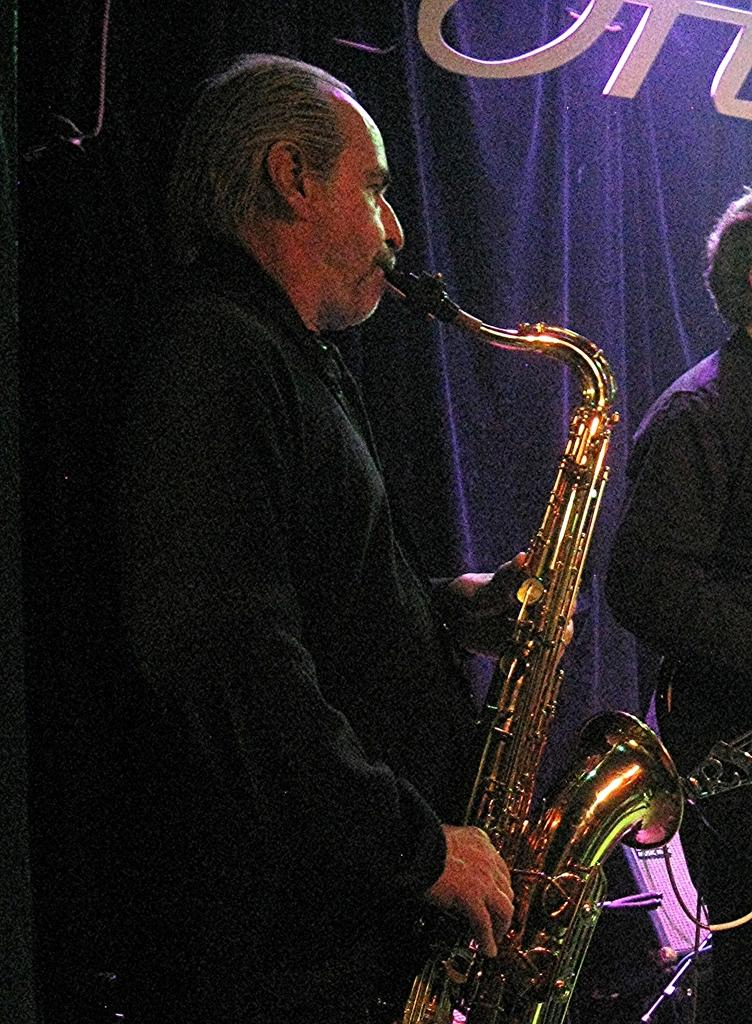What is the man in the image doing? The man is playing the trumpet. What is the man wearing in the image? The man is wearing a black color coat. Can you describe the person on the right side of the image? There is another person on the right side of the image, but no specific details are provided. What can be seen in the background of the image? There is a blue color curtain in the image. What type of match is the man playing in the image? There is no match or competition mentioned in the image; the man is simply playing the trumpet. Can you tell me how many knees the man has in the image? The number of knees is not relevant to the image, as it only shows the man playing the trumpet and does not focus on his body parts. 